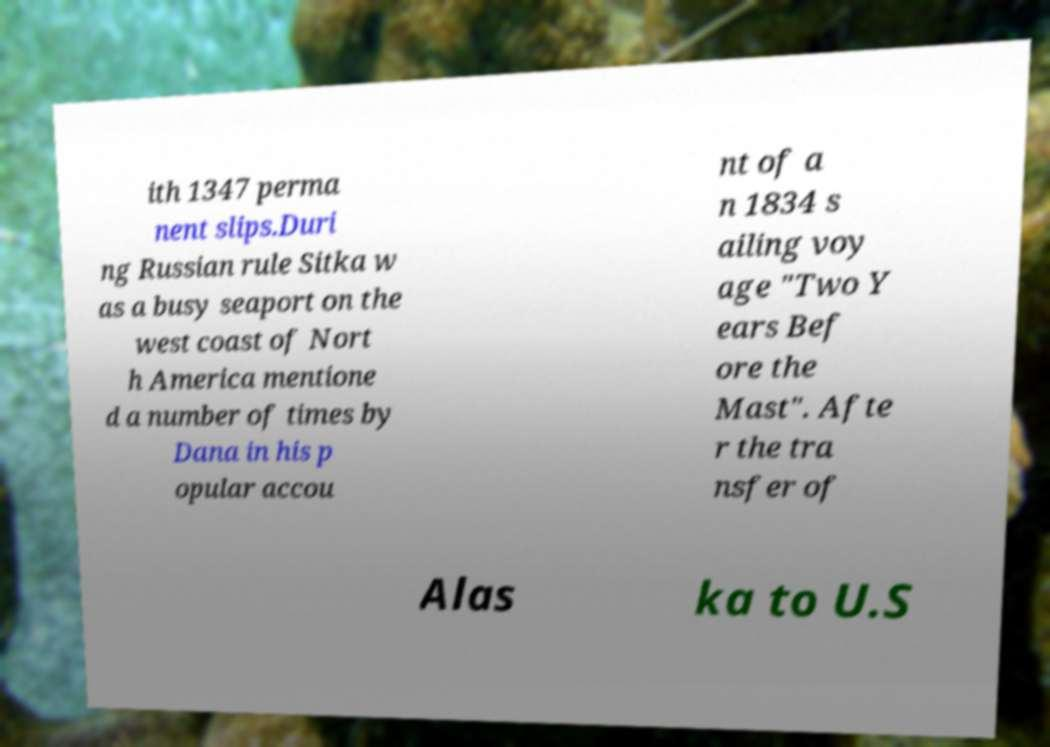What messages or text are displayed in this image? I need them in a readable, typed format. ith 1347 perma nent slips.Duri ng Russian rule Sitka w as a busy seaport on the west coast of Nort h America mentione d a number of times by Dana in his p opular accou nt of a n 1834 s ailing voy age "Two Y ears Bef ore the Mast". Afte r the tra nsfer of Alas ka to U.S 